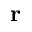Convert formula to latex. <formula><loc_0><loc_0><loc_500><loc_500>{ r }</formula> 